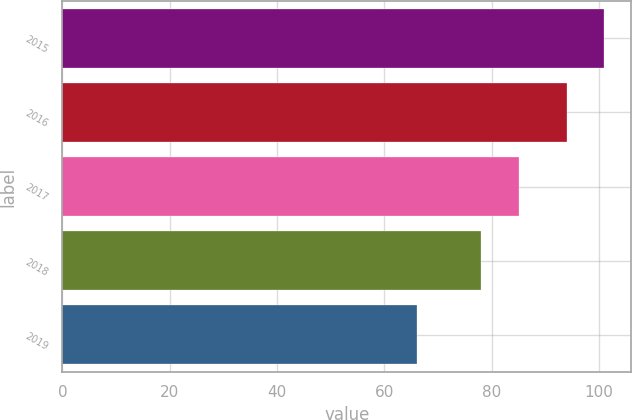Convert chart to OTSL. <chart><loc_0><loc_0><loc_500><loc_500><bar_chart><fcel>2015<fcel>2016<fcel>2017<fcel>2018<fcel>2019<nl><fcel>101<fcel>94<fcel>85<fcel>78<fcel>66<nl></chart> 